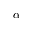<formula> <loc_0><loc_0><loc_500><loc_500>\alpha</formula> 